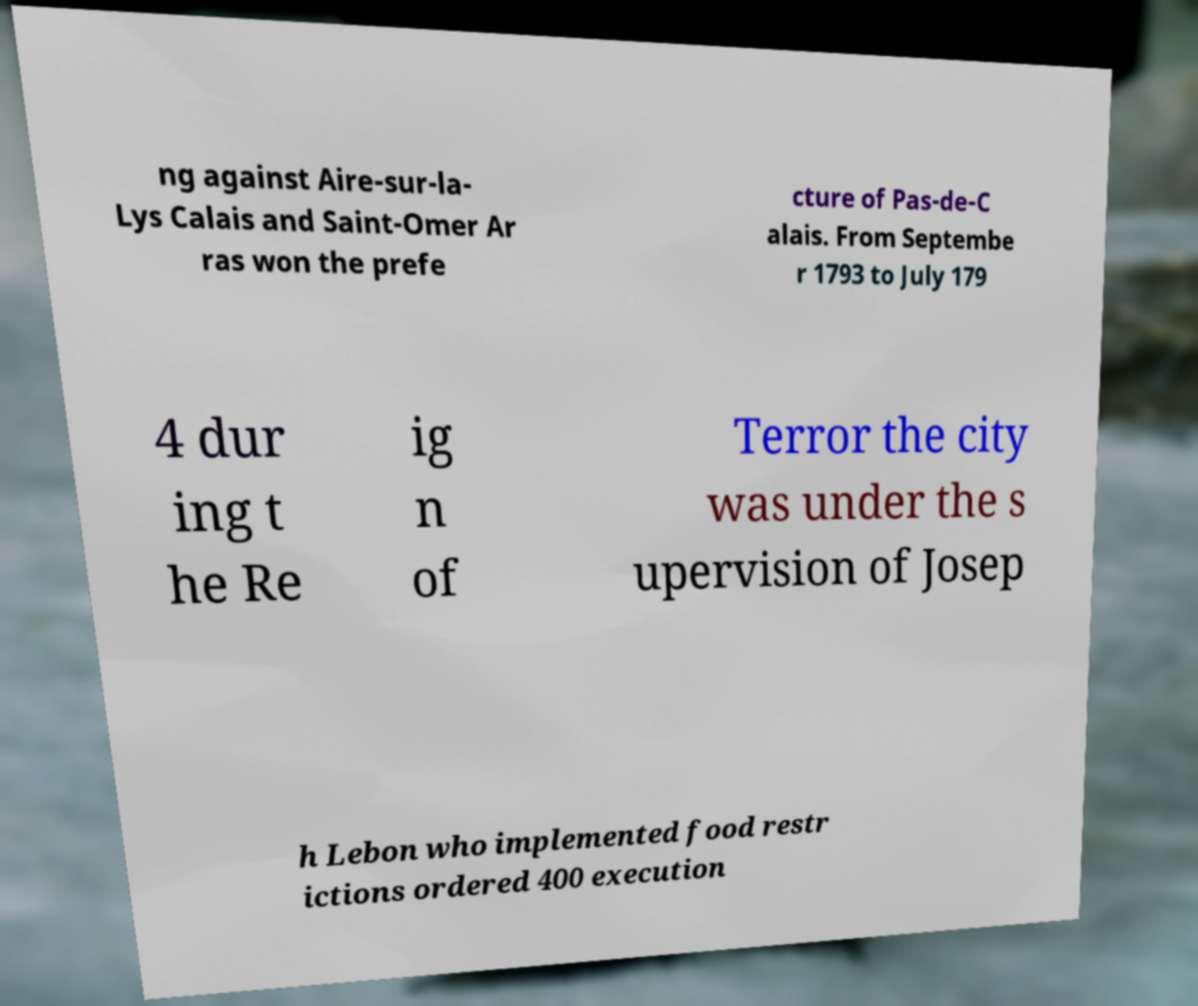Can you accurately transcribe the text from the provided image for me? ng against Aire-sur-la- Lys Calais and Saint-Omer Ar ras won the prefe cture of Pas-de-C alais. From Septembe r 1793 to July 179 4 dur ing t he Re ig n of Terror the city was under the s upervision of Josep h Lebon who implemented food restr ictions ordered 400 execution 